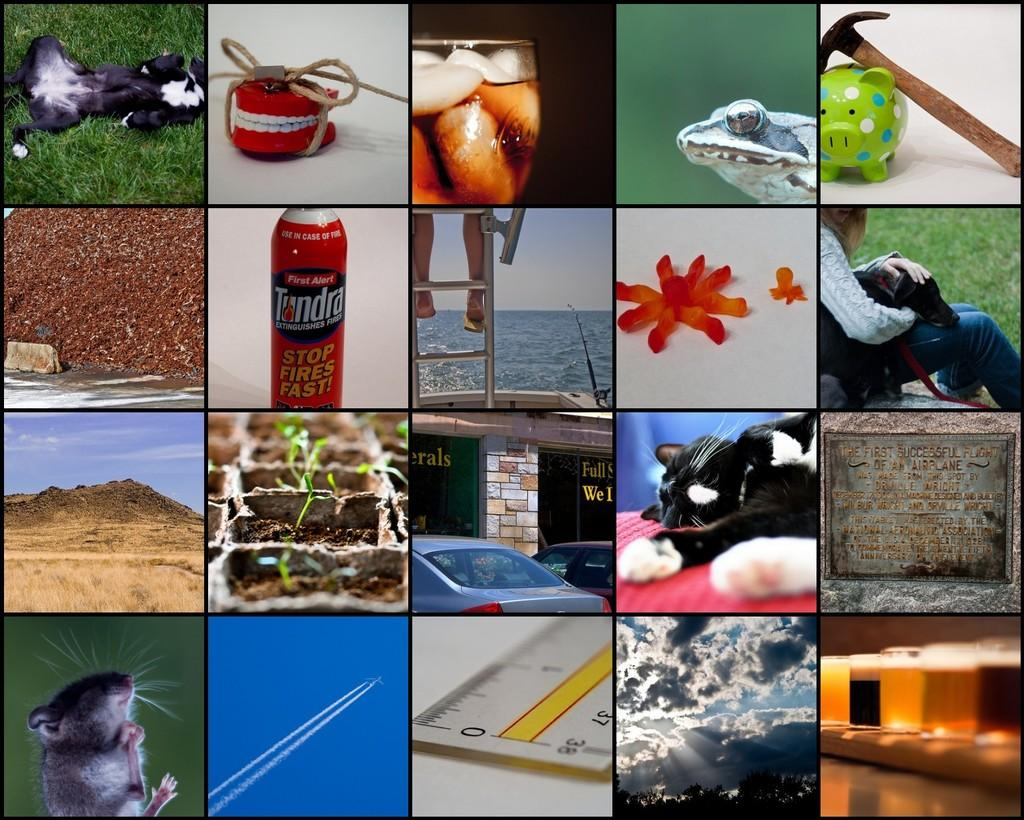What type of images can be found in the collage? The collage contains pictures of animals. Can you describe any specific elements within these animal pictures? Yes, there is water visible in one of the pictures, and a fire hydrant is visible in another picture. Are there any human-made objects present in the collage? Yes, glasses and a hammer are present in two of the pictures. What type of weather can be observed in one of the pictures? Clouds are visible in one of the pictures, suggesting a particular weather condition. Are there any living beings other than animals in the collage? Yes, a person is present in one of the pictures. How many quinces are present in the collage? There are no quinces present in the collage. Can you confirm the existence of a unicorn in the collage? There is no mention of a unicorn in the provided facts, so it cannot be confirmed. 